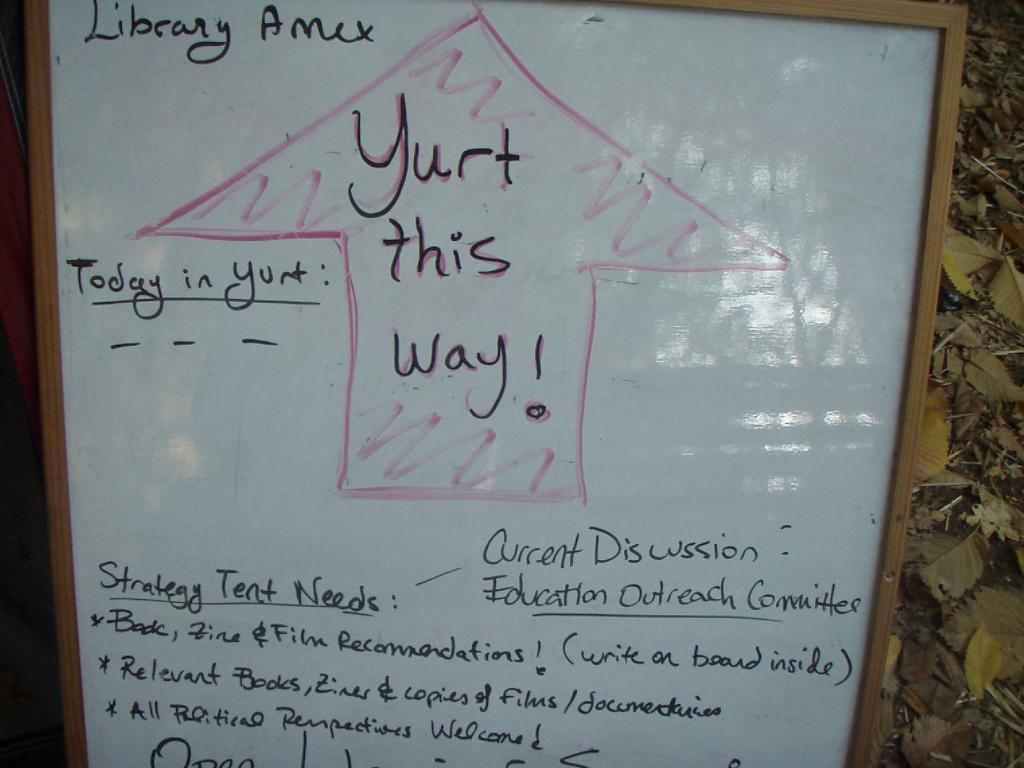<image>
Offer a succinct explanation of the picture presented. A Library Amex whiteboard drawing showing the way to Yurt. 